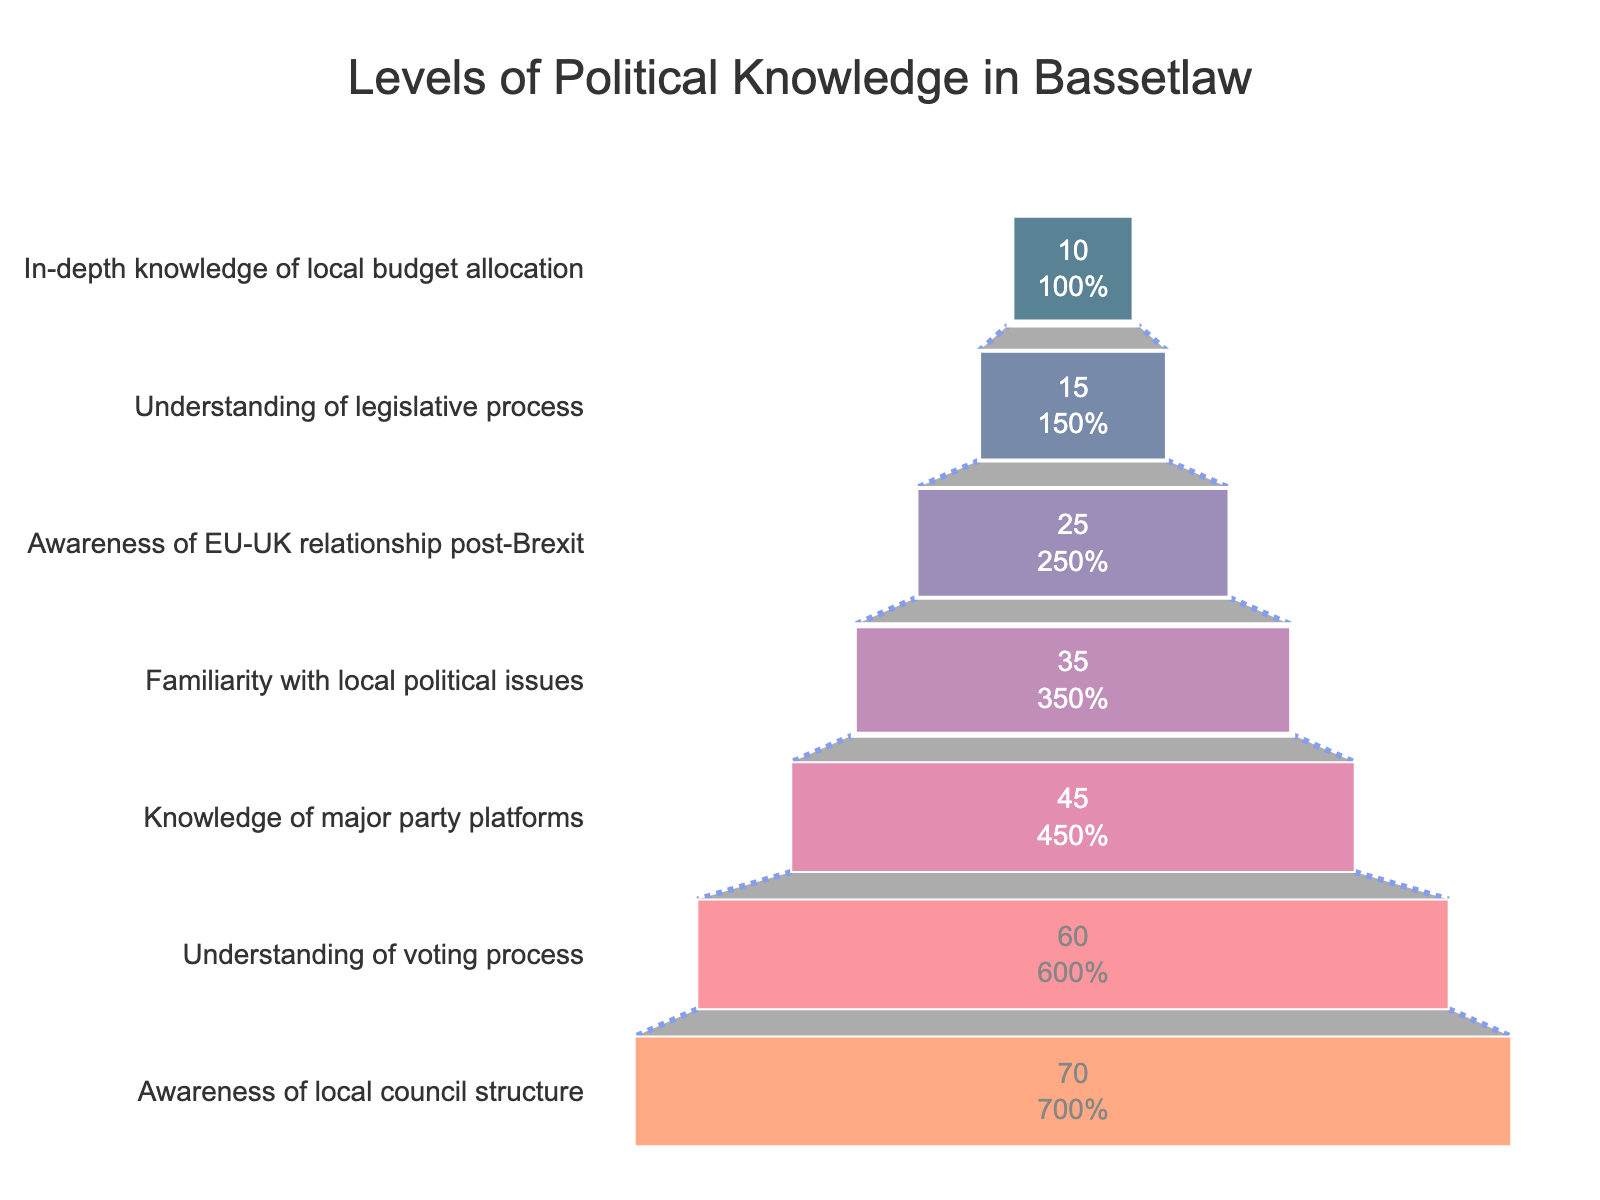What is the title of the figure? The title is usually displayed at the top or center of the figure and provides a summary of the content.
Answer: Levels of Political Knowledge in Bassetlaw Which level of political knowledge has the highest percentage of Bassetlaw residents? The highest percentage is the widest part at the top of the funnel chart, which indicates the level with the most residents.
Answer: Awareness of local council structure What percentage of Bassetlaw residents have an understanding of the voting process? Identify and read the percentage value next to the "Understanding of voting process" funnel segment.
Answer: 60% What is the difference in percentage between residents aware of local council structure and those with in-depth knowledge of local budget allocation? Subtract the percentage of the "In-depth knowledge of local budget allocation" segment from the "Awareness of local council structure" segment.
Answer: 60% Which two levels have a combined percentage of political knowledge that exceeds 100%? Sum the percentages of different segments and check which combinations exceed 100%.
Answer: Awareness of local council structure and Understanding of voting process Which level shows the least percentage of political knowledge among residents? The narrowest part at the bottom of the funnel chart indicates the level with the least residents.
Answer: In-depth knowledge of local budget allocation How does the percentage of residents familiar with local political issues compare to those aware of the EU-UK relationship post-Brexit? Compare the percentage values of the two specified levels directly.
Answer: 35% for local political issues, 25% for EU-UK relationship post-Brexit: local political issues are higher by 10% What is the percentage difference between residents' understanding of the legislative process and those familiar with local political issues? Subtract the percentage of the "Understanding of legislative process" from "Familiarity with local political issues".
Answer: 20% Which level marks the midpoint in terms of the percentage of political knowledge among the residents, and what is its value? Find the central level in the funnel chart and read its percentage.
Answer: Knowledge of major party platforms, 45% What color signifies the "Understanding of voting process" level? Identify the section labeled "Understanding of voting process" and note the color used for that segment.
Answer: Dark blue (or second darkest color used in the chart) 